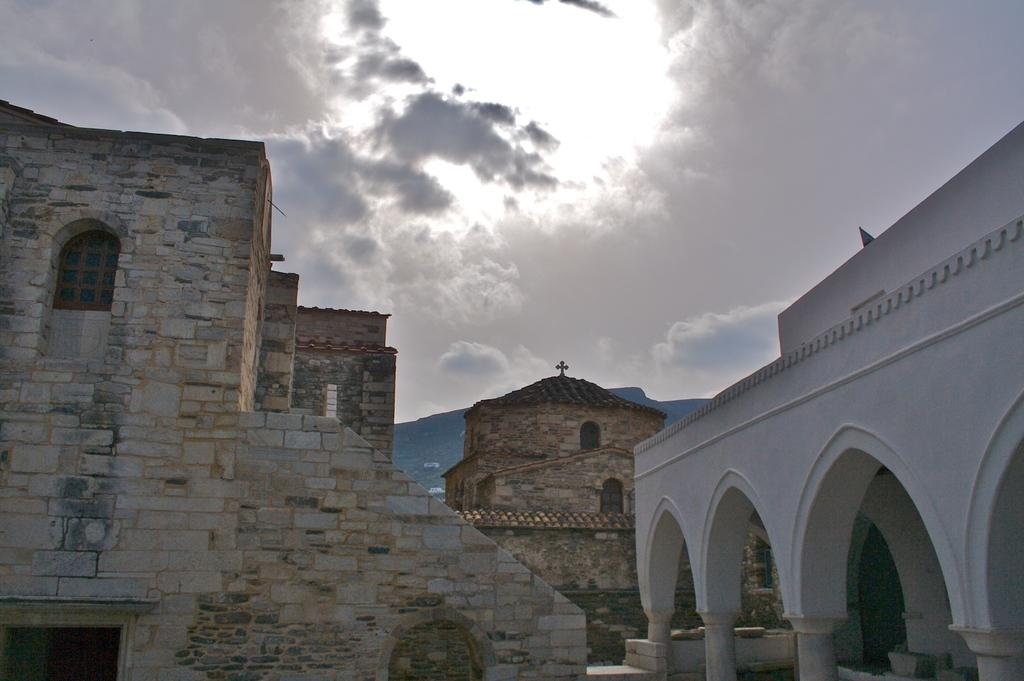What type of structures are present in the image? There are buildings in the image. What colors are the buildings? The buildings are in white, cream, and gray colors. What can be seen in the background of the image? The sky is visible in the background of the image. What colors are the sky? The sky is in white and gray colors. Where is the lamp placed in the image? There is no lamp present in the image. What type of good-bye gesture can be seen in the image? There is no good-bye gesture depicted in the image. 